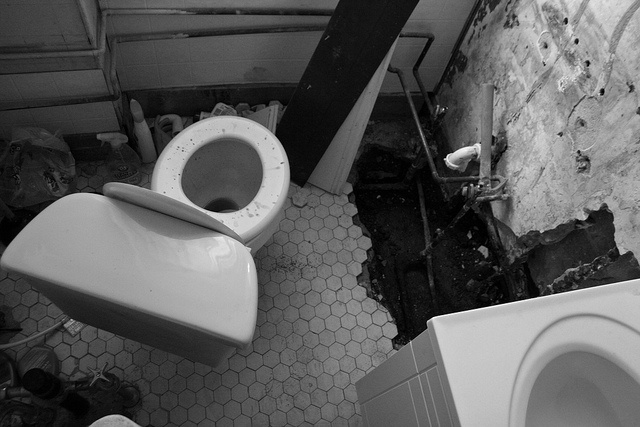Describe the objects in this image and their specific colors. I can see toilet in black, darkgray, gray, and lightgray tones, sink in darkgray, gray, silver, and black tones, bottle in black and gray tones, and bottle in black and gray tones in this image. 